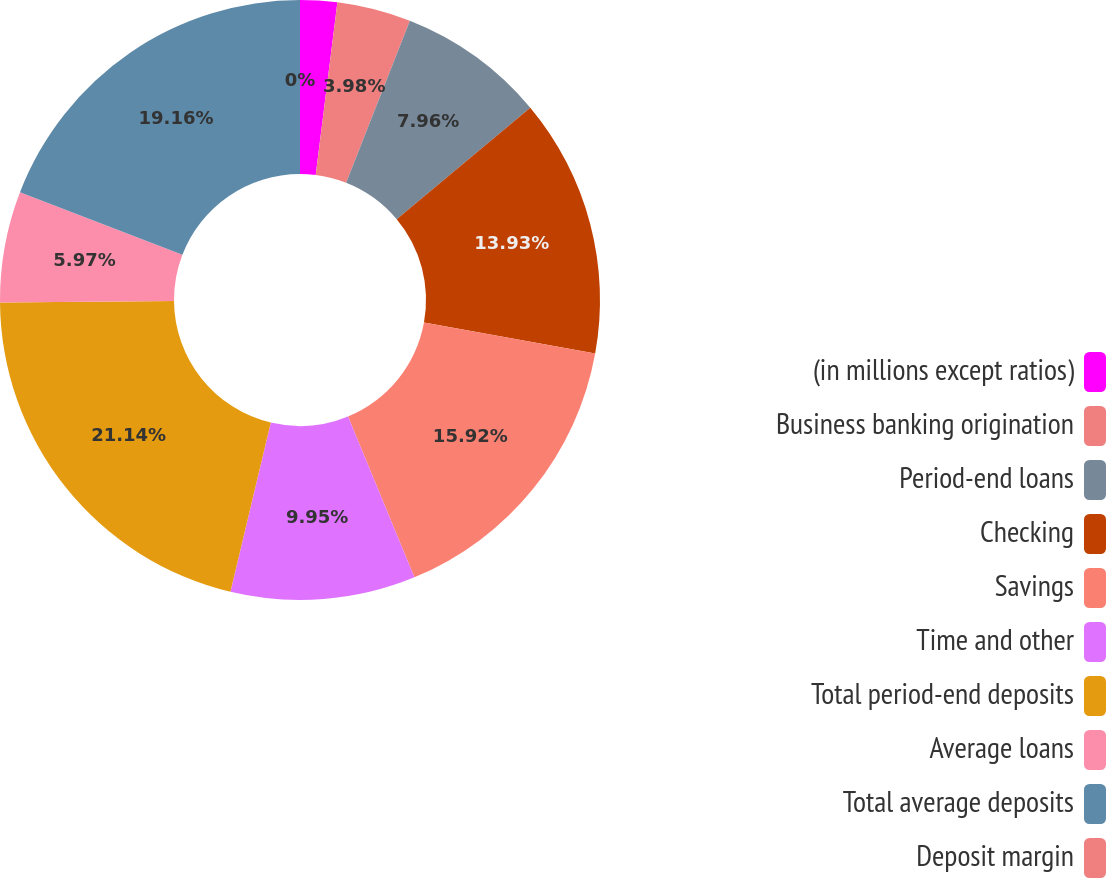Convert chart to OTSL. <chart><loc_0><loc_0><loc_500><loc_500><pie_chart><fcel>(in millions except ratios)<fcel>Business banking origination<fcel>Period-end loans<fcel>Checking<fcel>Savings<fcel>Time and other<fcel>Total period-end deposits<fcel>Average loans<fcel>Total average deposits<fcel>Deposit margin<nl><fcel>1.99%<fcel>3.98%<fcel>7.96%<fcel>13.93%<fcel>15.92%<fcel>9.95%<fcel>21.15%<fcel>5.97%<fcel>19.16%<fcel>0.0%<nl></chart> 